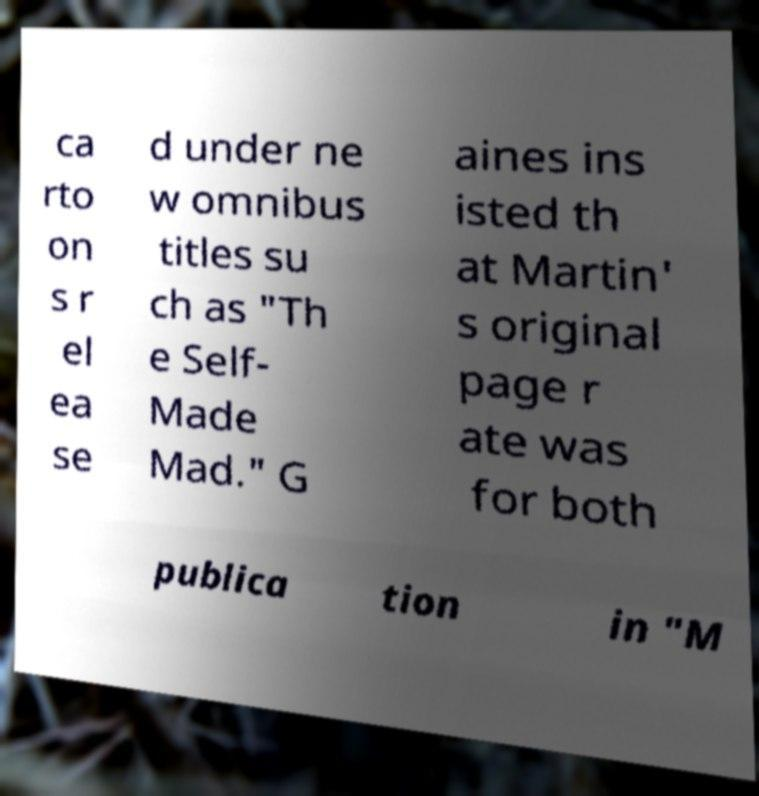Could you assist in decoding the text presented in this image and type it out clearly? ca rto on s r el ea se d under ne w omnibus titles su ch as "Th e Self- Made Mad." G aines ins isted th at Martin' s original page r ate was for both publica tion in "M 